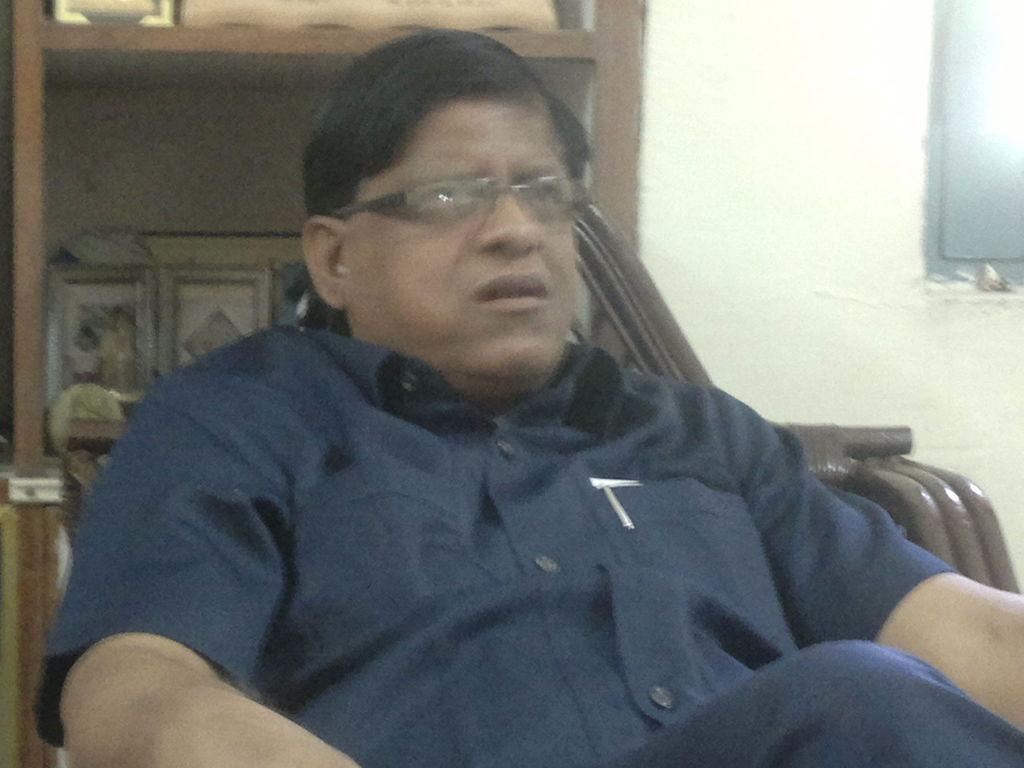What is the person in the image doing? There is a person sitting on a chair in the image. What can be seen in the background of the image? There is a shelf with photo frames in the background of the image. What is located on the right side of the image? There is a TV on the right side of the image. What type of cave can be seen in the image? There is no cave present in the image. What is the person reading in the image? The image does not show the person reading anything, so we cannot determine what they might be reading. 